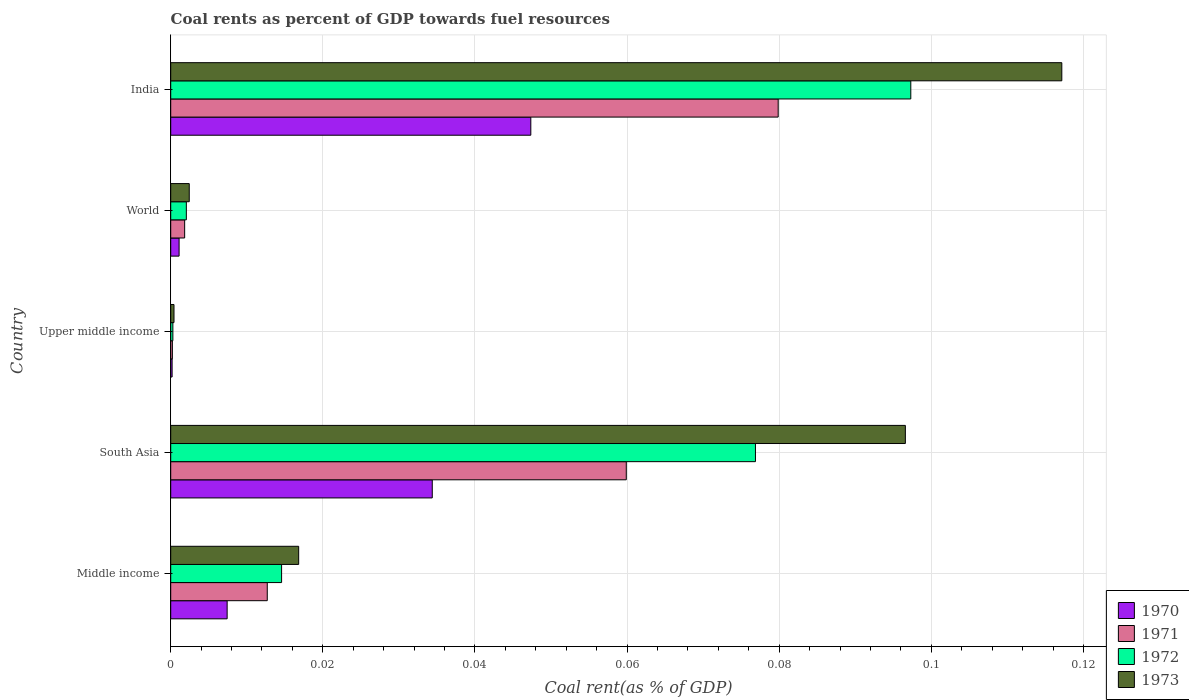Are the number of bars per tick equal to the number of legend labels?
Provide a short and direct response. Yes. Are the number of bars on each tick of the Y-axis equal?
Your response must be concise. Yes. What is the label of the 1st group of bars from the top?
Keep it short and to the point. India. In how many cases, is the number of bars for a given country not equal to the number of legend labels?
Offer a terse response. 0. What is the coal rent in 1970 in South Asia?
Provide a short and direct response. 0.03. Across all countries, what is the maximum coal rent in 1972?
Keep it short and to the point. 0.1. Across all countries, what is the minimum coal rent in 1970?
Offer a terse response. 0. In which country was the coal rent in 1972 maximum?
Your response must be concise. India. In which country was the coal rent in 1970 minimum?
Make the answer very short. Upper middle income. What is the total coal rent in 1973 in the graph?
Provide a short and direct response. 0.23. What is the difference between the coal rent in 1970 in Middle income and that in World?
Your answer should be compact. 0.01. What is the difference between the coal rent in 1971 in South Asia and the coal rent in 1972 in World?
Your answer should be compact. 0.06. What is the average coal rent in 1973 per country?
Ensure brevity in your answer.  0.05. What is the difference between the coal rent in 1970 and coal rent in 1971 in India?
Provide a short and direct response. -0.03. In how many countries, is the coal rent in 1970 greater than 0.016 %?
Your answer should be compact. 2. What is the ratio of the coal rent in 1970 in India to that in World?
Ensure brevity in your answer.  43.02. Is the coal rent in 1971 in Middle income less than that in Upper middle income?
Your answer should be compact. No. What is the difference between the highest and the second highest coal rent in 1970?
Make the answer very short. 0.01. What is the difference between the highest and the lowest coal rent in 1972?
Provide a succinct answer. 0.1. In how many countries, is the coal rent in 1971 greater than the average coal rent in 1971 taken over all countries?
Offer a terse response. 2. What does the 2nd bar from the top in World represents?
Ensure brevity in your answer.  1972. Is it the case that in every country, the sum of the coal rent in 1971 and coal rent in 1973 is greater than the coal rent in 1970?
Your response must be concise. Yes. How many countries are there in the graph?
Offer a terse response. 5. Are the values on the major ticks of X-axis written in scientific E-notation?
Give a very brief answer. No. Does the graph contain grids?
Provide a succinct answer. Yes. What is the title of the graph?
Keep it short and to the point. Coal rents as percent of GDP towards fuel resources. Does "1984" appear as one of the legend labels in the graph?
Your answer should be very brief. No. What is the label or title of the X-axis?
Offer a very short reply. Coal rent(as % of GDP). What is the Coal rent(as % of GDP) in 1970 in Middle income?
Provide a succinct answer. 0.01. What is the Coal rent(as % of GDP) in 1971 in Middle income?
Your answer should be very brief. 0.01. What is the Coal rent(as % of GDP) of 1972 in Middle income?
Give a very brief answer. 0.01. What is the Coal rent(as % of GDP) in 1973 in Middle income?
Keep it short and to the point. 0.02. What is the Coal rent(as % of GDP) in 1970 in South Asia?
Offer a terse response. 0.03. What is the Coal rent(as % of GDP) of 1971 in South Asia?
Make the answer very short. 0.06. What is the Coal rent(as % of GDP) of 1972 in South Asia?
Offer a terse response. 0.08. What is the Coal rent(as % of GDP) of 1973 in South Asia?
Your answer should be very brief. 0.1. What is the Coal rent(as % of GDP) in 1970 in Upper middle income?
Offer a very short reply. 0. What is the Coal rent(as % of GDP) of 1971 in Upper middle income?
Make the answer very short. 0. What is the Coal rent(as % of GDP) of 1972 in Upper middle income?
Your answer should be compact. 0. What is the Coal rent(as % of GDP) in 1973 in Upper middle income?
Keep it short and to the point. 0. What is the Coal rent(as % of GDP) in 1970 in World?
Offer a terse response. 0. What is the Coal rent(as % of GDP) in 1971 in World?
Provide a succinct answer. 0. What is the Coal rent(as % of GDP) of 1972 in World?
Offer a terse response. 0. What is the Coal rent(as % of GDP) in 1973 in World?
Make the answer very short. 0. What is the Coal rent(as % of GDP) in 1970 in India?
Your answer should be compact. 0.05. What is the Coal rent(as % of GDP) in 1971 in India?
Your response must be concise. 0.08. What is the Coal rent(as % of GDP) of 1972 in India?
Offer a very short reply. 0.1. What is the Coal rent(as % of GDP) of 1973 in India?
Your response must be concise. 0.12. Across all countries, what is the maximum Coal rent(as % of GDP) of 1970?
Your response must be concise. 0.05. Across all countries, what is the maximum Coal rent(as % of GDP) of 1971?
Your answer should be compact. 0.08. Across all countries, what is the maximum Coal rent(as % of GDP) of 1972?
Provide a short and direct response. 0.1. Across all countries, what is the maximum Coal rent(as % of GDP) in 1973?
Give a very brief answer. 0.12. Across all countries, what is the minimum Coal rent(as % of GDP) of 1970?
Your answer should be very brief. 0. Across all countries, what is the minimum Coal rent(as % of GDP) of 1971?
Ensure brevity in your answer.  0. Across all countries, what is the minimum Coal rent(as % of GDP) in 1972?
Your response must be concise. 0. Across all countries, what is the minimum Coal rent(as % of GDP) of 1973?
Provide a succinct answer. 0. What is the total Coal rent(as % of GDP) of 1970 in the graph?
Make the answer very short. 0.09. What is the total Coal rent(as % of GDP) in 1971 in the graph?
Your answer should be compact. 0.15. What is the total Coal rent(as % of GDP) of 1972 in the graph?
Your answer should be very brief. 0.19. What is the total Coal rent(as % of GDP) of 1973 in the graph?
Make the answer very short. 0.23. What is the difference between the Coal rent(as % of GDP) of 1970 in Middle income and that in South Asia?
Ensure brevity in your answer.  -0.03. What is the difference between the Coal rent(as % of GDP) of 1971 in Middle income and that in South Asia?
Provide a short and direct response. -0.05. What is the difference between the Coal rent(as % of GDP) in 1972 in Middle income and that in South Asia?
Offer a terse response. -0.06. What is the difference between the Coal rent(as % of GDP) of 1973 in Middle income and that in South Asia?
Offer a terse response. -0.08. What is the difference between the Coal rent(as % of GDP) in 1970 in Middle income and that in Upper middle income?
Make the answer very short. 0.01. What is the difference between the Coal rent(as % of GDP) in 1971 in Middle income and that in Upper middle income?
Ensure brevity in your answer.  0.01. What is the difference between the Coal rent(as % of GDP) in 1972 in Middle income and that in Upper middle income?
Make the answer very short. 0.01. What is the difference between the Coal rent(as % of GDP) of 1973 in Middle income and that in Upper middle income?
Your answer should be compact. 0.02. What is the difference between the Coal rent(as % of GDP) of 1970 in Middle income and that in World?
Keep it short and to the point. 0.01. What is the difference between the Coal rent(as % of GDP) of 1971 in Middle income and that in World?
Your answer should be very brief. 0.01. What is the difference between the Coal rent(as % of GDP) of 1972 in Middle income and that in World?
Make the answer very short. 0.01. What is the difference between the Coal rent(as % of GDP) of 1973 in Middle income and that in World?
Your answer should be compact. 0.01. What is the difference between the Coal rent(as % of GDP) in 1970 in Middle income and that in India?
Make the answer very short. -0.04. What is the difference between the Coal rent(as % of GDP) in 1971 in Middle income and that in India?
Your answer should be compact. -0.07. What is the difference between the Coal rent(as % of GDP) in 1972 in Middle income and that in India?
Make the answer very short. -0.08. What is the difference between the Coal rent(as % of GDP) of 1973 in Middle income and that in India?
Keep it short and to the point. -0.1. What is the difference between the Coal rent(as % of GDP) of 1970 in South Asia and that in Upper middle income?
Your answer should be very brief. 0.03. What is the difference between the Coal rent(as % of GDP) of 1971 in South Asia and that in Upper middle income?
Ensure brevity in your answer.  0.06. What is the difference between the Coal rent(as % of GDP) in 1972 in South Asia and that in Upper middle income?
Offer a very short reply. 0.08. What is the difference between the Coal rent(as % of GDP) of 1973 in South Asia and that in Upper middle income?
Offer a very short reply. 0.1. What is the difference between the Coal rent(as % of GDP) of 1971 in South Asia and that in World?
Provide a short and direct response. 0.06. What is the difference between the Coal rent(as % of GDP) in 1972 in South Asia and that in World?
Provide a short and direct response. 0.07. What is the difference between the Coal rent(as % of GDP) in 1973 in South Asia and that in World?
Ensure brevity in your answer.  0.09. What is the difference between the Coal rent(as % of GDP) of 1970 in South Asia and that in India?
Give a very brief answer. -0.01. What is the difference between the Coal rent(as % of GDP) in 1971 in South Asia and that in India?
Keep it short and to the point. -0.02. What is the difference between the Coal rent(as % of GDP) in 1972 in South Asia and that in India?
Your response must be concise. -0.02. What is the difference between the Coal rent(as % of GDP) in 1973 in South Asia and that in India?
Your answer should be compact. -0.02. What is the difference between the Coal rent(as % of GDP) in 1970 in Upper middle income and that in World?
Provide a short and direct response. -0. What is the difference between the Coal rent(as % of GDP) in 1971 in Upper middle income and that in World?
Offer a terse response. -0. What is the difference between the Coal rent(as % of GDP) in 1972 in Upper middle income and that in World?
Offer a terse response. -0. What is the difference between the Coal rent(as % of GDP) in 1973 in Upper middle income and that in World?
Your response must be concise. -0. What is the difference between the Coal rent(as % of GDP) of 1970 in Upper middle income and that in India?
Make the answer very short. -0.05. What is the difference between the Coal rent(as % of GDP) of 1971 in Upper middle income and that in India?
Provide a succinct answer. -0.08. What is the difference between the Coal rent(as % of GDP) in 1972 in Upper middle income and that in India?
Make the answer very short. -0.1. What is the difference between the Coal rent(as % of GDP) of 1973 in Upper middle income and that in India?
Ensure brevity in your answer.  -0.12. What is the difference between the Coal rent(as % of GDP) in 1970 in World and that in India?
Offer a terse response. -0.05. What is the difference between the Coal rent(as % of GDP) of 1971 in World and that in India?
Provide a succinct answer. -0.08. What is the difference between the Coal rent(as % of GDP) of 1972 in World and that in India?
Your response must be concise. -0.1. What is the difference between the Coal rent(as % of GDP) of 1973 in World and that in India?
Your response must be concise. -0.11. What is the difference between the Coal rent(as % of GDP) of 1970 in Middle income and the Coal rent(as % of GDP) of 1971 in South Asia?
Your answer should be very brief. -0.05. What is the difference between the Coal rent(as % of GDP) in 1970 in Middle income and the Coal rent(as % of GDP) in 1972 in South Asia?
Your answer should be very brief. -0.07. What is the difference between the Coal rent(as % of GDP) in 1970 in Middle income and the Coal rent(as % of GDP) in 1973 in South Asia?
Ensure brevity in your answer.  -0.09. What is the difference between the Coal rent(as % of GDP) of 1971 in Middle income and the Coal rent(as % of GDP) of 1972 in South Asia?
Your answer should be very brief. -0.06. What is the difference between the Coal rent(as % of GDP) in 1971 in Middle income and the Coal rent(as % of GDP) in 1973 in South Asia?
Offer a very short reply. -0.08. What is the difference between the Coal rent(as % of GDP) in 1972 in Middle income and the Coal rent(as % of GDP) in 1973 in South Asia?
Keep it short and to the point. -0.08. What is the difference between the Coal rent(as % of GDP) of 1970 in Middle income and the Coal rent(as % of GDP) of 1971 in Upper middle income?
Provide a succinct answer. 0.01. What is the difference between the Coal rent(as % of GDP) of 1970 in Middle income and the Coal rent(as % of GDP) of 1972 in Upper middle income?
Offer a very short reply. 0.01. What is the difference between the Coal rent(as % of GDP) in 1970 in Middle income and the Coal rent(as % of GDP) in 1973 in Upper middle income?
Provide a short and direct response. 0.01. What is the difference between the Coal rent(as % of GDP) of 1971 in Middle income and the Coal rent(as % of GDP) of 1972 in Upper middle income?
Provide a succinct answer. 0.01. What is the difference between the Coal rent(as % of GDP) in 1971 in Middle income and the Coal rent(as % of GDP) in 1973 in Upper middle income?
Keep it short and to the point. 0.01. What is the difference between the Coal rent(as % of GDP) in 1972 in Middle income and the Coal rent(as % of GDP) in 1973 in Upper middle income?
Your answer should be compact. 0.01. What is the difference between the Coal rent(as % of GDP) in 1970 in Middle income and the Coal rent(as % of GDP) in 1971 in World?
Offer a terse response. 0.01. What is the difference between the Coal rent(as % of GDP) of 1970 in Middle income and the Coal rent(as % of GDP) of 1972 in World?
Your response must be concise. 0.01. What is the difference between the Coal rent(as % of GDP) in 1970 in Middle income and the Coal rent(as % of GDP) in 1973 in World?
Keep it short and to the point. 0.01. What is the difference between the Coal rent(as % of GDP) of 1971 in Middle income and the Coal rent(as % of GDP) of 1972 in World?
Keep it short and to the point. 0.01. What is the difference between the Coal rent(as % of GDP) in 1971 in Middle income and the Coal rent(as % of GDP) in 1973 in World?
Your answer should be very brief. 0.01. What is the difference between the Coal rent(as % of GDP) of 1972 in Middle income and the Coal rent(as % of GDP) of 1973 in World?
Offer a terse response. 0.01. What is the difference between the Coal rent(as % of GDP) in 1970 in Middle income and the Coal rent(as % of GDP) in 1971 in India?
Your answer should be very brief. -0.07. What is the difference between the Coal rent(as % of GDP) of 1970 in Middle income and the Coal rent(as % of GDP) of 1972 in India?
Make the answer very short. -0.09. What is the difference between the Coal rent(as % of GDP) of 1970 in Middle income and the Coal rent(as % of GDP) of 1973 in India?
Your answer should be very brief. -0.11. What is the difference between the Coal rent(as % of GDP) of 1971 in Middle income and the Coal rent(as % of GDP) of 1972 in India?
Your response must be concise. -0.08. What is the difference between the Coal rent(as % of GDP) of 1971 in Middle income and the Coal rent(as % of GDP) of 1973 in India?
Your response must be concise. -0.1. What is the difference between the Coal rent(as % of GDP) in 1972 in Middle income and the Coal rent(as % of GDP) in 1973 in India?
Ensure brevity in your answer.  -0.1. What is the difference between the Coal rent(as % of GDP) in 1970 in South Asia and the Coal rent(as % of GDP) in 1971 in Upper middle income?
Offer a very short reply. 0.03. What is the difference between the Coal rent(as % of GDP) in 1970 in South Asia and the Coal rent(as % of GDP) in 1972 in Upper middle income?
Keep it short and to the point. 0.03. What is the difference between the Coal rent(as % of GDP) in 1970 in South Asia and the Coal rent(as % of GDP) in 1973 in Upper middle income?
Ensure brevity in your answer.  0.03. What is the difference between the Coal rent(as % of GDP) in 1971 in South Asia and the Coal rent(as % of GDP) in 1972 in Upper middle income?
Give a very brief answer. 0.06. What is the difference between the Coal rent(as % of GDP) of 1971 in South Asia and the Coal rent(as % of GDP) of 1973 in Upper middle income?
Your response must be concise. 0.06. What is the difference between the Coal rent(as % of GDP) in 1972 in South Asia and the Coal rent(as % of GDP) in 1973 in Upper middle income?
Keep it short and to the point. 0.08. What is the difference between the Coal rent(as % of GDP) of 1970 in South Asia and the Coal rent(as % of GDP) of 1971 in World?
Ensure brevity in your answer.  0.03. What is the difference between the Coal rent(as % of GDP) of 1970 in South Asia and the Coal rent(as % of GDP) of 1972 in World?
Your answer should be compact. 0.03. What is the difference between the Coal rent(as % of GDP) of 1970 in South Asia and the Coal rent(as % of GDP) of 1973 in World?
Your response must be concise. 0.03. What is the difference between the Coal rent(as % of GDP) in 1971 in South Asia and the Coal rent(as % of GDP) in 1972 in World?
Ensure brevity in your answer.  0.06. What is the difference between the Coal rent(as % of GDP) in 1971 in South Asia and the Coal rent(as % of GDP) in 1973 in World?
Your answer should be very brief. 0.06. What is the difference between the Coal rent(as % of GDP) in 1972 in South Asia and the Coal rent(as % of GDP) in 1973 in World?
Offer a very short reply. 0.07. What is the difference between the Coal rent(as % of GDP) in 1970 in South Asia and the Coal rent(as % of GDP) in 1971 in India?
Offer a very short reply. -0.05. What is the difference between the Coal rent(as % of GDP) in 1970 in South Asia and the Coal rent(as % of GDP) in 1972 in India?
Keep it short and to the point. -0.06. What is the difference between the Coal rent(as % of GDP) of 1970 in South Asia and the Coal rent(as % of GDP) of 1973 in India?
Keep it short and to the point. -0.08. What is the difference between the Coal rent(as % of GDP) in 1971 in South Asia and the Coal rent(as % of GDP) in 1972 in India?
Offer a very short reply. -0.04. What is the difference between the Coal rent(as % of GDP) of 1971 in South Asia and the Coal rent(as % of GDP) of 1973 in India?
Give a very brief answer. -0.06. What is the difference between the Coal rent(as % of GDP) of 1972 in South Asia and the Coal rent(as % of GDP) of 1973 in India?
Make the answer very short. -0.04. What is the difference between the Coal rent(as % of GDP) of 1970 in Upper middle income and the Coal rent(as % of GDP) of 1971 in World?
Offer a terse response. -0. What is the difference between the Coal rent(as % of GDP) in 1970 in Upper middle income and the Coal rent(as % of GDP) in 1972 in World?
Your answer should be compact. -0. What is the difference between the Coal rent(as % of GDP) in 1970 in Upper middle income and the Coal rent(as % of GDP) in 1973 in World?
Offer a very short reply. -0. What is the difference between the Coal rent(as % of GDP) of 1971 in Upper middle income and the Coal rent(as % of GDP) of 1972 in World?
Your response must be concise. -0. What is the difference between the Coal rent(as % of GDP) in 1971 in Upper middle income and the Coal rent(as % of GDP) in 1973 in World?
Give a very brief answer. -0. What is the difference between the Coal rent(as % of GDP) of 1972 in Upper middle income and the Coal rent(as % of GDP) of 1973 in World?
Keep it short and to the point. -0. What is the difference between the Coal rent(as % of GDP) of 1970 in Upper middle income and the Coal rent(as % of GDP) of 1971 in India?
Your answer should be compact. -0.08. What is the difference between the Coal rent(as % of GDP) in 1970 in Upper middle income and the Coal rent(as % of GDP) in 1972 in India?
Offer a terse response. -0.1. What is the difference between the Coal rent(as % of GDP) in 1970 in Upper middle income and the Coal rent(as % of GDP) in 1973 in India?
Your answer should be compact. -0.12. What is the difference between the Coal rent(as % of GDP) of 1971 in Upper middle income and the Coal rent(as % of GDP) of 1972 in India?
Your answer should be compact. -0.1. What is the difference between the Coal rent(as % of GDP) of 1971 in Upper middle income and the Coal rent(as % of GDP) of 1973 in India?
Ensure brevity in your answer.  -0.12. What is the difference between the Coal rent(as % of GDP) in 1972 in Upper middle income and the Coal rent(as % of GDP) in 1973 in India?
Your answer should be compact. -0.12. What is the difference between the Coal rent(as % of GDP) of 1970 in World and the Coal rent(as % of GDP) of 1971 in India?
Make the answer very short. -0.08. What is the difference between the Coal rent(as % of GDP) of 1970 in World and the Coal rent(as % of GDP) of 1972 in India?
Your answer should be very brief. -0.1. What is the difference between the Coal rent(as % of GDP) of 1970 in World and the Coal rent(as % of GDP) of 1973 in India?
Offer a very short reply. -0.12. What is the difference between the Coal rent(as % of GDP) of 1971 in World and the Coal rent(as % of GDP) of 1972 in India?
Offer a very short reply. -0.1. What is the difference between the Coal rent(as % of GDP) of 1971 in World and the Coal rent(as % of GDP) of 1973 in India?
Make the answer very short. -0.12. What is the difference between the Coal rent(as % of GDP) of 1972 in World and the Coal rent(as % of GDP) of 1973 in India?
Keep it short and to the point. -0.12. What is the average Coal rent(as % of GDP) of 1970 per country?
Your answer should be very brief. 0.02. What is the average Coal rent(as % of GDP) of 1971 per country?
Provide a short and direct response. 0.03. What is the average Coal rent(as % of GDP) of 1972 per country?
Offer a very short reply. 0.04. What is the average Coal rent(as % of GDP) in 1973 per country?
Provide a short and direct response. 0.05. What is the difference between the Coal rent(as % of GDP) in 1970 and Coal rent(as % of GDP) in 1971 in Middle income?
Offer a very short reply. -0.01. What is the difference between the Coal rent(as % of GDP) of 1970 and Coal rent(as % of GDP) of 1972 in Middle income?
Provide a succinct answer. -0.01. What is the difference between the Coal rent(as % of GDP) of 1970 and Coal rent(as % of GDP) of 1973 in Middle income?
Offer a very short reply. -0.01. What is the difference between the Coal rent(as % of GDP) in 1971 and Coal rent(as % of GDP) in 1972 in Middle income?
Your answer should be compact. -0. What is the difference between the Coal rent(as % of GDP) of 1971 and Coal rent(as % of GDP) of 1973 in Middle income?
Provide a succinct answer. -0. What is the difference between the Coal rent(as % of GDP) of 1972 and Coal rent(as % of GDP) of 1973 in Middle income?
Provide a short and direct response. -0. What is the difference between the Coal rent(as % of GDP) of 1970 and Coal rent(as % of GDP) of 1971 in South Asia?
Offer a very short reply. -0.03. What is the difference between the Coal rent(as % of GDP) in 1970 and Coal rent(as % of GDP) in 1972 in South Asia?
Provide a succinct answer. -0.04. What is the difference between the Coal rent(as % of GDP) of 1970 and Coal rent(as % of GDP) of 1973 in South Asia?
Offer a very short reply. -0.06. What is the difference between the Coal rent(as % of GDP) of 1971 and Coal rent(as % of GDP) of 1972 in South Asia?
Provide a short and direct response. -0.02. What is the difference between the Coal rent(as % of GDP) of 1971 and Coal rent(as % of GDP) of 1973 in South Asia?
Provide a succinct answer. -0.04. What is the difference between the Coal rent(as % of GDP) of 1972 and Coal rent(as % of GDP) of 1973 in South Asia?
Offer a terse response. -0.02. What is the difference between the Coal rent(as % of GDP) in 1970 and Coal rent(as % of GDP) in 1971 in Upper middle income?
Provide a succinct answer. -0. What is the difference between the Coal rent(as % of GDP) of 1970 and Coal rent(as % of GDP) of 1972 in Upper middle income?
Offer a terse response. -0. What is the difference between the Coal rent(as % of GDP) of 1970 and Coal rent(as % of GDP) of 1973 in Upper middle income?
Your answer should be very brief. -0. What is the difference between the Coal rent(as % of GDP) in 1971 and Coal rent(as % of GDP) in 1972 in Upper middle income?
Keep it short and to the point. -0. What is the difference between the Coal rent(as % of GDP) in 1971 and Coal rent(as % of GDP) in 1973 in Upper middle income?
Your response must be concise. -0. What is the difference between the Coal rent(as % of GDP) in 1972 and Coal rent(as % of GDP) in 1973 in Upper middle income?
Ensure brevity in your answer.  -0. What is the difference between the Coal rent(as % of GDP) of 1970 and Coal rent(as % of GDP) of 1971 in World?
Your response must be concise. -0. What is the difference between the Coal rent(as % of GDP) in 1970 and Coal rent(as % of GDP) in 1972 in World?
Offer a very short reply. -0. What is the difference between the Coal rent(as % of GDP) in 1970 and Coal rent(as % of GDP) in 1973 in World?
Your response must be concise. -0. What is the difference between the Coal rent(as % of GDP) of 1971 and Coal rent(as % of GDP) of 1972 in World?
Your answer should be compact. -0. What is the difference between the Coal rent(as % of GDP) in 1971 and Coal rent(as % of GDP) in 1973 in World?
Ensure brevity in your answer.  -0. What is the difference between the Coal rent(as % of GDP) of 1972 and Coal rent(as % of GDP) of 1973 in World?
Offer a very short reply. -0. What is the difference between the Coal rent(as % of GDP) in 1970 and Coal rent(as % of GDP) in 1971 in India?
Offer a very short reply. -0.03. What is the difference between the Coal rent(as % of GDP) in 1970 and Coal rent(as % of GDP) in 1973 in India?
Make the answer very short. -0.07. What is the difference between the Coal rent(as % of GDP) of 1971 and Coal rent(as % of GDP) of 1972 in India?
Make the answer very short. -0.02. What is the difference between the Coal rent(as % of GDP) of 1971 and Coal rent(as % of GDP) of 1973 in India?
Your answer should be compact. -0.04. What is the difference between the Coal rent(as % of GDP) in 1972 and Coal rent(as % of GDP) in 1973 in India?
Provide a succinct answer. -0.02. What is the ratio of the Coal rent(as % of GDP) of 1970 in Middle income to that in South Asia?
Make the answer very short. 0.22. What is the ratio of the Coal rent(as % of GDP) in 1971 in Middle income to that in South Asia?
Provide a short and direct response. 0.21. What is the ratio of the Coal rent(as % of GDP) in 1972 in Middle income to that in South Asia?
Ensure brevity in your answer.  0.19. What is the ratio of the Coal rent(as % of GDP) in 1973 in Middle income to that in South Asia?
Provide a succinct answer. 0.17. What is the ratio of the Coal rent(as % of GDP) in 1970 in Middle income to that in Upper middle income?
Offer a very short reply. 40.36. What is the ratio of the Coal rent(as % of GDP) of 1971 in Middle income to that in Upper middle income?
Ensure brevity in your answer.  58.01. What is the ratio of the Coal rent(as % of GDP) of 1972 in Middle income to that in Upper middle income?
Offer a terse response. 51.25. What is the ratio of the Coal rent(as % of GDP) in 1973 in Middle income to that in Upper middle income?
Keep it short and to the point. 39.04. What is the ratio of the Coal rent(as % of GDP) in 1970 in Middle income to that in World?
Offer a very short reply. 6.74. What is the ratio of the Coal rent(as % of GDP) of 1971 in Middle income to that in World?
Offer a terse response. 6.93. What is the ratio of the Coal rent(as % of GDP) in 1972 in Middle income to that in World?
Offer a terse response. 7.09. What is the ratio of the Coal rent(as % of GDP) in 1973 in Middle income to that in World?
Offer a very short reply. 6.91. What is the ratio of the Coal rent(as % of GDP) of 1970 in Middle income to that in India?
Ensure brevity in your answer.  0.16. What is the ratio of the Coal rent(as % of GDP) in 1971 in Middle income to that in India?
Ensure brevity in your answer.  0.16. What is the ratio of the Coal rent(as % of GDP) in 1972 in Middle income to that in India?
Offer a terse response. 0.15. What is the ratio of the Coal rent(as % of GDP) of 1973 in Middle income to that in India?
Your response must be concise. 0.14. What is the ratio of the Coal rent(as % of GDP) of 1970 in South Asia to that in Upper middle income?
Ensure brevity in your answer.  187.05. What is the ratio of the Coal rent(as % of GDP) in 1971 in South Asia to that in Upper middle income?
Ensure brevity in your answer.  273.74. What is the ratio of the Coal rent(as % of GDP) in 1972 in South Asia to that in Upper middle income?
Make the answer very short. 270.32. What is the ratio of the Coal rent(as % of GDP) in 1973 in South Asia to that in Upper middle income?
Offer a terse response. 224.18. What is the ratio of the Coal rent(as % of GDP) in 1970 in South Asia to that in World?
Offer a very short reply. 31.24. What is the ratio of the Coal rent(as % of GDP) in 1971 in South Asia to that in World?
Your answer should be compact. 32.69. What is the ratio of the Coal rent(as % of GDP) of 1972 in South Asia to that in World?
Keep it short and to the point. 37.41. What is the ratio of the Coal rent(as % of GDP) of 1973 in South Asia to that in World?
Make the answer very short. 39.65. What is the ratio of the Coal rent(as % of GDP) of 1970 in South Asia to that in India?
Provide a succinct answer. 0.73. What is the ratio of the Coal rent(as % of GDP) of 1971 in South Asia to that in India?
Offer a terse response. 0.75. What is the ratio of the Coal rent(as % of GDP) of 1972 in South Asia to that in India?
Your response must be concise. 0.79. What is the ratio of the Coal rent(as % of GDP) of 1973 in South Asia to that in India?
Keep it short and to the point. 0.82. What is the ratio of the Coal rent(as % of GDP) of 1970 in Upper middle income to that in World?
Give a very brief answer. 0.17. What is the ratio of the Coal rent(as % of GDP) in 1971 in Upper middle income to that in World?
Offer a terse response. 0.12. What is the ratio of the Coal rent(as % of GDP) of 1972 in Upper middle income to that in World?
Ensure brevity in your answer.  0.14. What is the ratio of the Coal rent(as % of GDP) in 1973 in Upper middle income to that in World?
Keep it short and to the point. 0.18. What is the ratio of the Coal rent(as % of GDP) of 1970 in Upper middle income to that in India?
Keep it short and to the point. 0. What is the ratio of the Coal rent(as % of GDP) of 1971 in Upper middle income to that in India?
Offer a terse response. 0. What is the ratio of the Coal rent(as % of GDP) in 1972 in Upper middle income to that in India?
Ensure brevity in your answer.  0. What is the ratio of the Coal rent(as % of GDP) of 1973 in Upper middle income to that in India?
Provide a short and direct response. 0. What is the ratio of the Coal rent(as % of GDP) in 1970 in World to that in India?
Ensure brevity in your answer.  0.02. What is the ratio of the Coal rent(as % of GDP) in 1971 in World to that in India?
Keep it short and to the point. 0.02. What is the ratio of the Coal rent(as % of GDP) of 1972 in World to that in India?
Your answer should be very brief. 0.02. What is the ratio of the Coal rent(as % of GDP) in 1973 in World to that in India?
Your answer should be very brief. 0.02. What is the difference between the highest and the second highest Coal rent(as % of GDP) in 1970?
Your answer should be very brief. 0.01. What is the difference between the highest and the second highest Coal rent(as % of GDP) in 1971?
Give a very brief answer. 0.02. What is the difference between the highest and the second highest Coal rent(as % of GDP) of 1972?
Offer a terse response. 0.02. What is the difference between the highest and the second highest Coal rent(as % of GDP) of 1973?
Offer a very short reply. 0.02. What is the difference between the highest and the lowest Coal rent(as % of GDP) in 1970?
Provide a short and direct response. 0.05. What is the difference between the highest and the lowest Coal rent(as % of GDP) in 1971?
Offer a very short reply. 0.08. What is the difference between the highest and the lowest Coal rent(as % of GDP) of 1972?
Make the answer very short. 0.1. What is the difference between the highest and the lowest Coal rent(as % of GDP) of 1973?
Your answer should be compact. 0.12. 